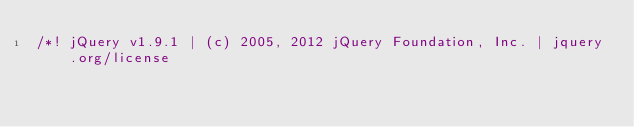<code> <loc_0><loc_0><loc_500><loc_500><_JavaScript_>/*! jQuery v1.9.1 | (c) 2005, 2012 jQuery Foundation, Inc. | jquery.org/license
</code> 